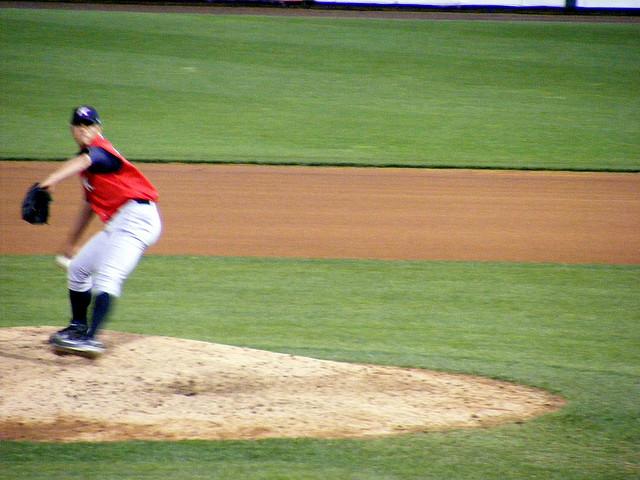What is the color shirt?
Concise answer only. Red. What field position does this baseball player play?
Give a very brief answer. Pitcher. What sport is this?
Give a very brief answer. Baseball. 